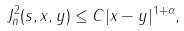<formula> <loc_0><loc_0><loc_500><loc_500>J ^ { 2 } _ { n } ( s , x , y ) \leq C | x - y | ^ { 1 + \alpha } ,</formula> 